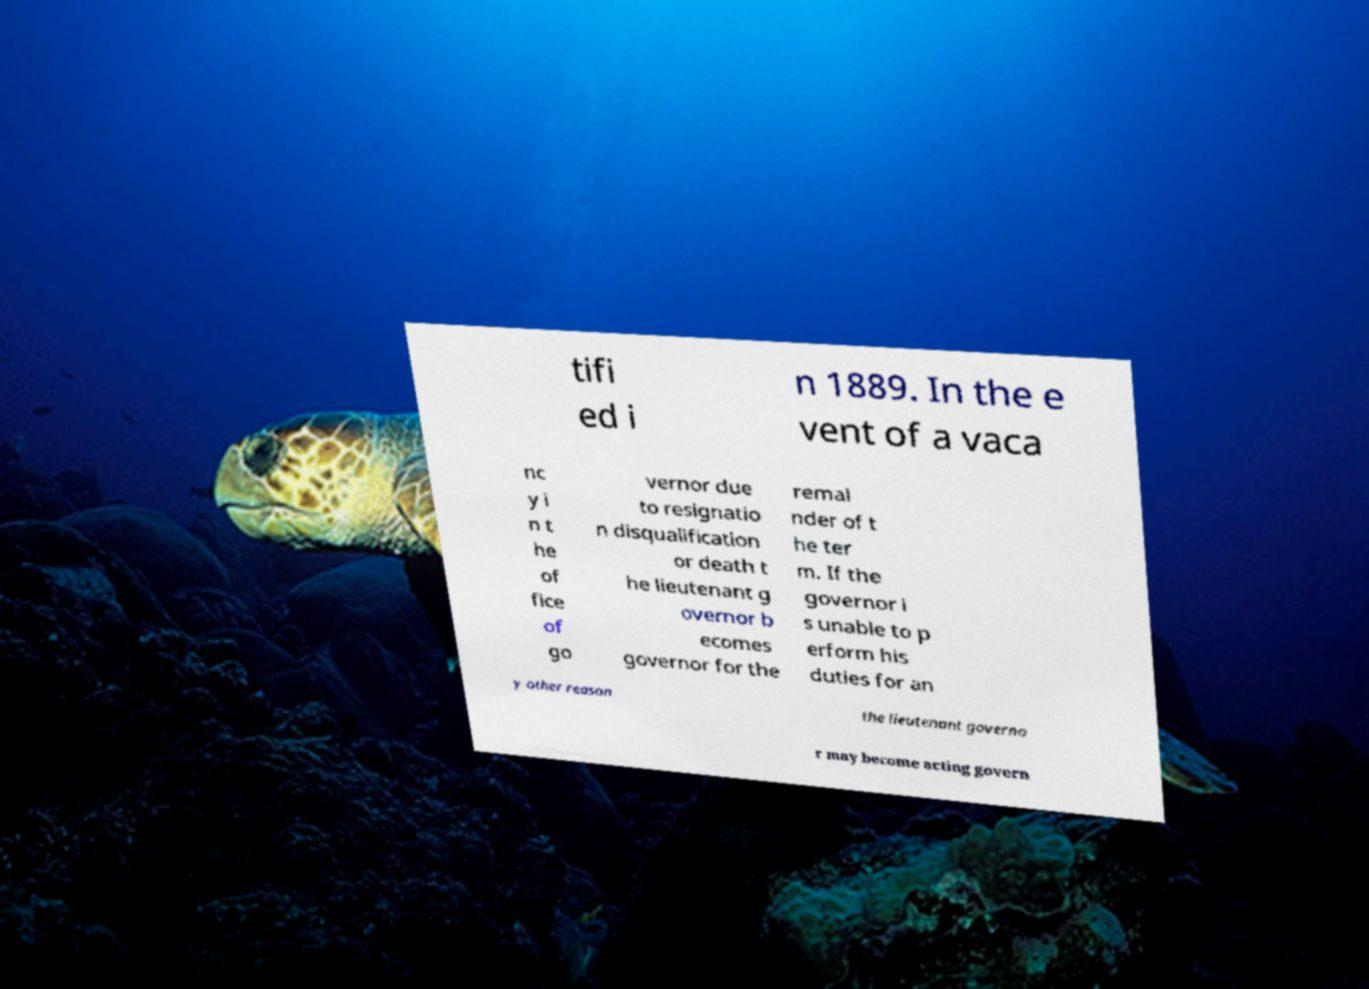Can you read and provide the text displayed in the image?This photo seems to have some interesting text. Can you extract and type it out for me? tifi ed i n 1889. In the e vent of a vaca nc y i n t he of fice of go vernor due to resignatio n disqualification or death t he lieutenant g overnor b ecomes governor for the remai nder of t he ter m. If the governor i s unable to p erform his duties for an y other reason the lieutenant governo r may become acting govern 